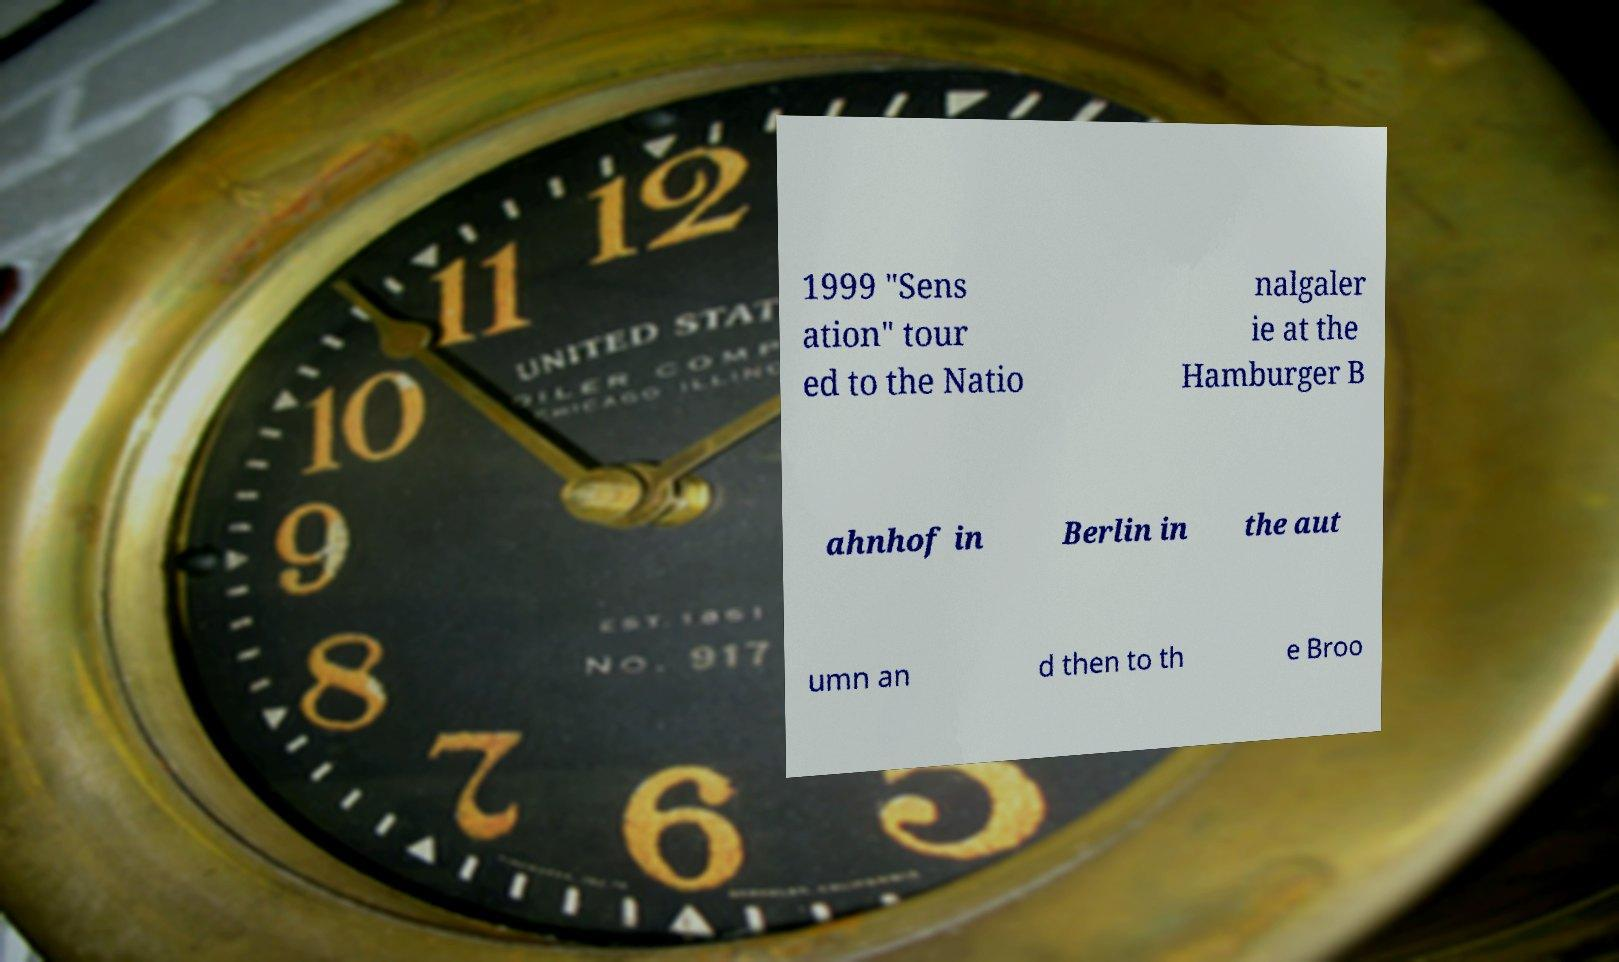Could you assist in decoding the text presented in this image and type it out clearly? 1999 "Sens ation" tour ed to the Natio nalgaler ie at the Hamburger B ahnhof in Berlin in the aut umn an d then to th e Broo 